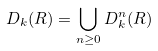<formula> <loc_0><loc_0><loc_500><loc_500>D _ { k } ( R ) = \bigcup _ { n \geq 0 } D _ { k } ^ { n } ( R )</formula> 